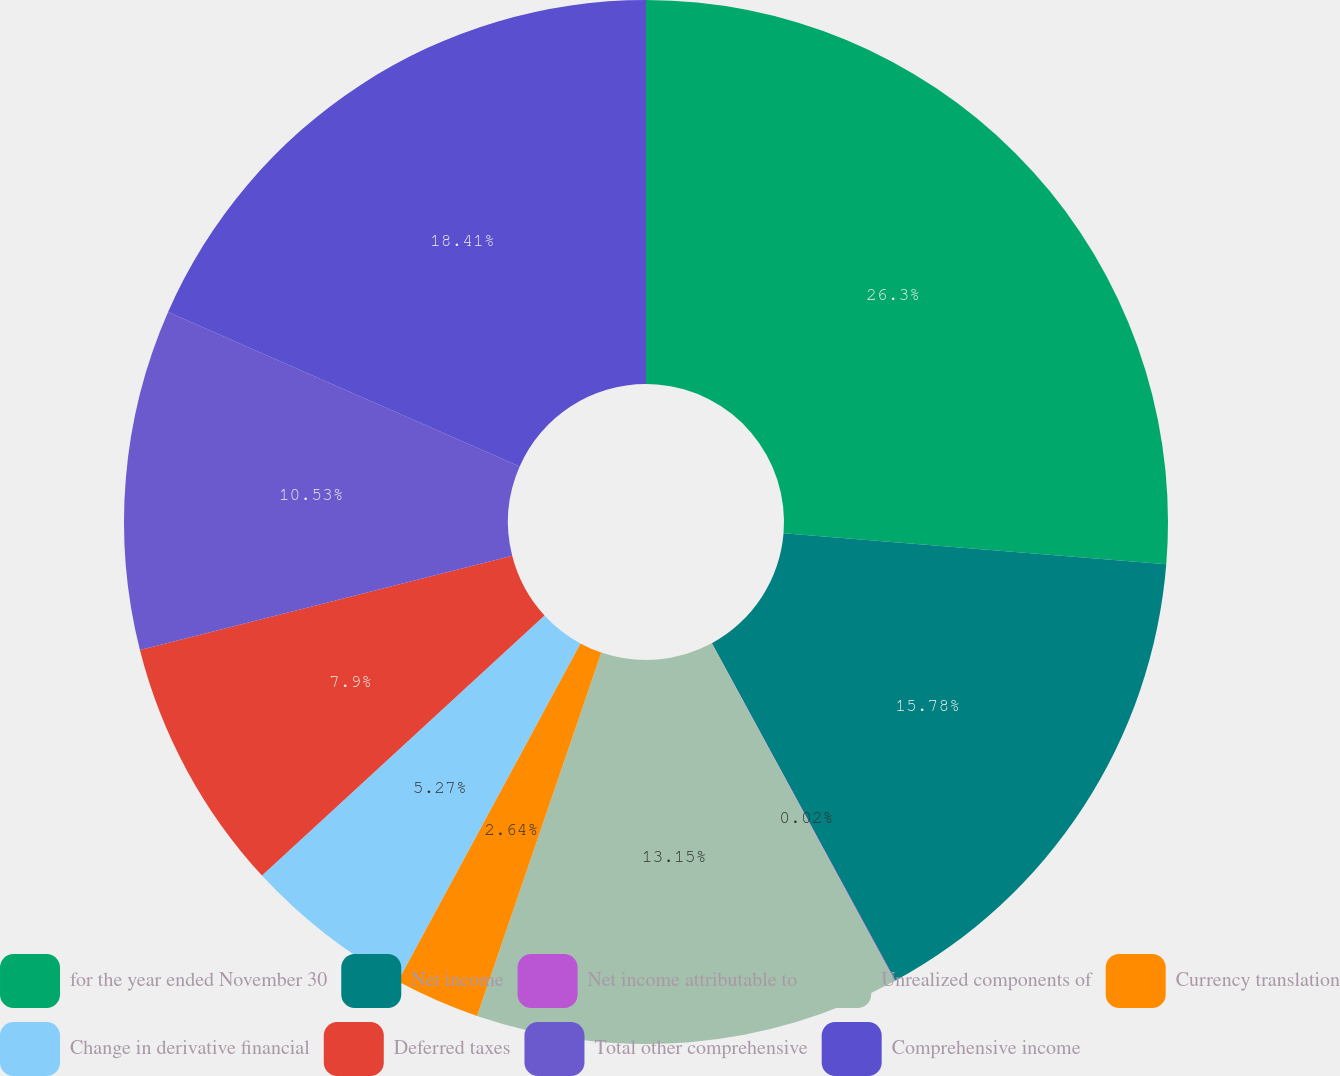Convert chart to OTSL. <chart><loc_0><loc_0><loc_500><loc_500><pie_chart><fcel>for the year ended November 30<fcel>Net income<fcel>Net income attributable to<fcel>Unrealized components of<fcel>Currency translation<fcel>Change in derivative financial<fcel>Deferred taxes<fcel>Total other comprehensive<fcel>Comprehensive income<nl><fcel>26.29%<fcel>15.78%<fcel>0.02%<fcel>13.15%<fcel>2.64%<fcel>5.27%<fcel>7.9%<fcel>10.53%<fcel>18.41%<nl></chart> 